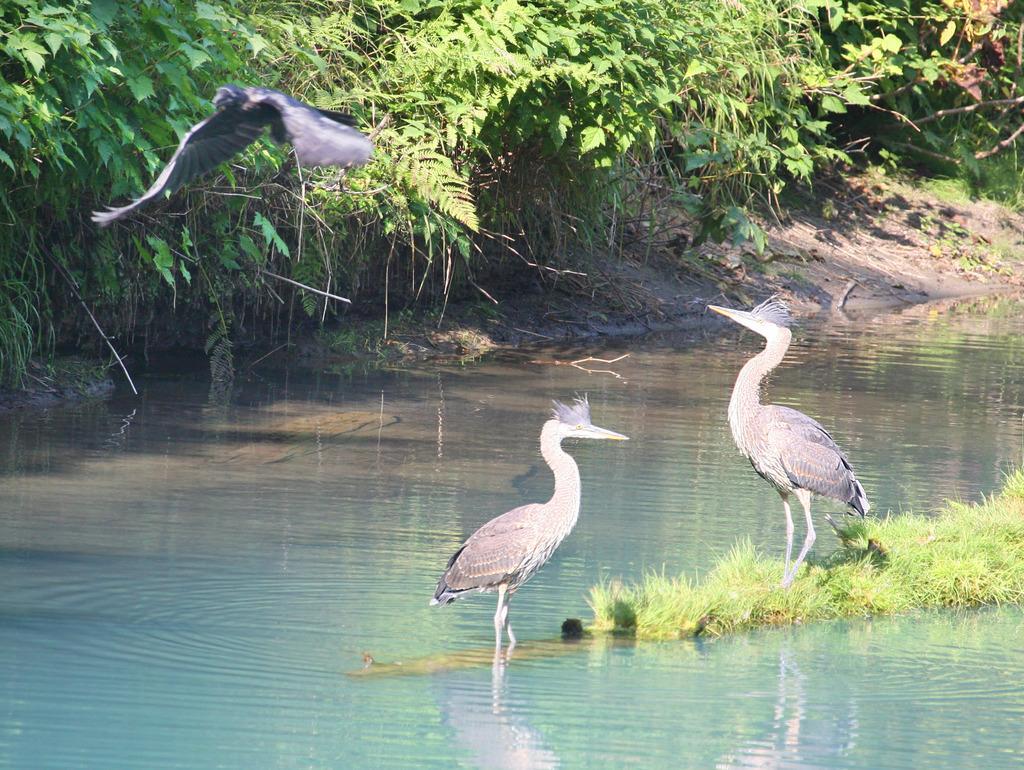How would you summarize this image in a sentence or two? On water there are two birds. Here we can see grass and plants. This bird is flying in the air with wings. 